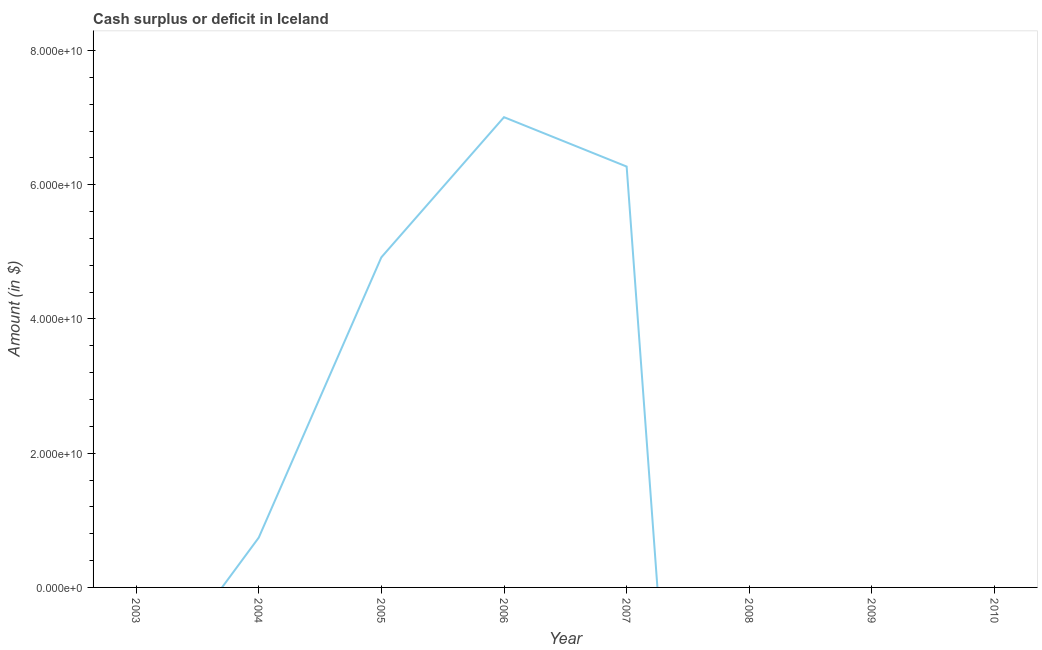What is the cash surplus or deficit in 2003?
Your answer should be very brief. 0. Across all years, what is the maximum cash surplus or deficit?
Offer a very short reply. 7.01e+1. What is the sum of the cash surplus or deficit?
Provide a succinct answer. 1.89e+11. What is the difference between the cash surplus or deficit in 2004 and 2007?
Your response must be concise. -5.53e+1. What is the average cash surplus or deficit per year?
Offer a terse response. 2.37e+1. What is the median cash surplus or deficit?
Make the answer very short. 3.71e+09. In how many years, is the cash surplus or deficit greater than 52000000000 $?
Your response must be concise. 2. Is the cash surplus or deficit in 2006 less than that in 2007?
Offer a very short reply. No. What is the difference between the highest and the second highest cash surplus or deficit?
Offer a terse response. 7.36e+09. What is the difference between the highest and the lowest cash surplus or deficit?
Keep it short and to the point. 7.01e+1. In how many years, is the cash surplus or deficit greater than the average cash surplus or deficit taken over all years?
Provide a short and direct response. 3. How many lines are there?
Offer a very short reply. 1. Are the values on the major ticks of Y-axis written in scientific E-notation?
Make the answer very short. Yes. What is the title of the graph?
Your answer should be very brief. Cash surplus or deficit in Iceland. What is the label or title of the X-axis?
Keep it short and to the point. Year. What is the label or title of the Y-axis?
Provide a succinct answer. Amount (in $). What is the Amount (in $) in 2004?
Your answer should be very brief. 7.41e+09. What is the Amount (in $) of 2005?
Ensure brevity in your answer.  4.92e+1. What is the Amount (in $) of 2006?
Your response must be concise. 7.01e+1. What is the Amount (in $) of 2007?
Offer a very short reply. 6.27e+1. What is the Amount (in $) of 2008?
Give a very brief answer. 0. What is the Amount (in $) of 2009?
Keep it short and to the point. 0. What is the difference between the Amount (in $) in 2004 and 2005?
Make the answer very short. -4.18e+1. What is the difference between the Amount (in $) in 2004 and 2006?
Your answer should be compact. -6.27e+1. What is the difference between the Amount (in $) in 2004 and 2007?
Give a very brief answer. -5.53e+1. What is the difference between the Amount (in $) in 2005 and 2006?
Your response must be concise. -2.09e+1. What is the difference between the Amount (in $) in 2005 and 2007?
Provide a short and direct response. -1.35e+1. What is the difference between the Amount (in $) in 2006 and 2007?
Keep it short and to the point. 7.36e+09. What is the ratio of the Amount (in $) in 2004 to that in 2005?
Provide a succinct answer. 0.15. What is the ratio of the Amount (in $) in 2004 to that in 2006?
Offer a very short reply. 0.11. What is the ratio of the Amount (in $) in 2004 to that in 2007?
Ensure brevity in your answer.  0.12. What is the ratio of the Amount (in $) in 2005 to that in 2006?
Provide a short and direct response. 0.7. What is the ratio of the Amount (in $) in 2005 to that in 2007?
Provide a short and direct response. 0.78. What is the ratio of the Amount (in $) in 2006 to that in 2007?
Give a very brief answer. 1.12. 